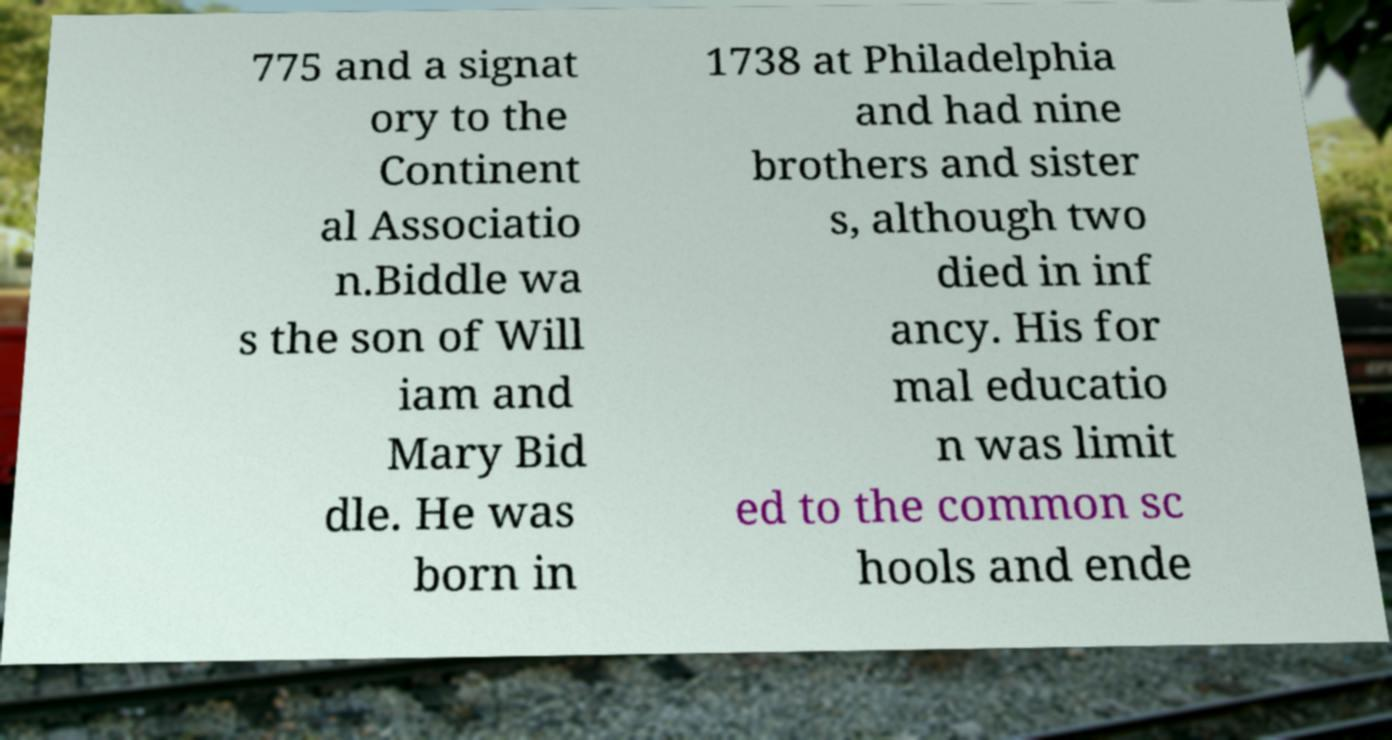Can you read and provide the text displayed in the image?This photo seems to have some interesting text. Can you extract and type it out for me? 775 and a signat ory to the Continent al Associatio n.Biddle wa s the son of Will iam and Mary Bid dle. He was born in 1738 at Philadelphia and had nine brothers and sister s, although two died in inf ancy. His for mal educatio n was limit ed to the common sc hools and ende 